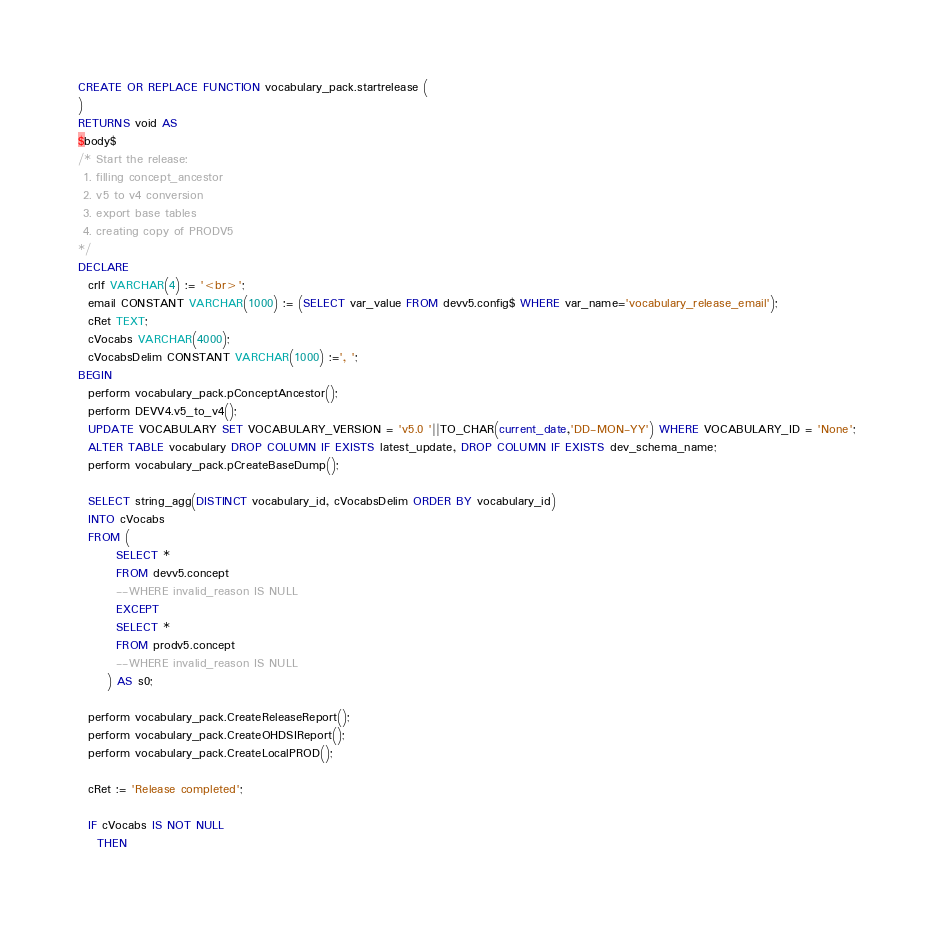Convert code to text. <code><loc_0><loc_0><loc_500><loc_500><_SQL_>CREATE OR REPLACE FUNCTION vocabulary_pack.startrelease (
)
RETURNS void AS
$body$
/* Start the release: 
 1. filling concept_ancestor 
 2. v5 to v4 conversion
 3. export base tables
 4. creating copy of PRODV5
*/
DECLARE
  crlf VARCHAR(4) := '<br>';
  email CONSTANT VARCHAR(1000) := (SELECT var_value FROM devv5.config$ WHERE var_name='vocabulary_release_email');
  cRet TEXT;
  cVocabs VARCHAR(4000);
  cVocabsDelim CONSTANT VARCHAR(1000) :=', ';
BEGIN
  perform vocabulary_pack.pConceptAncestor();
  perform DEVV4.v5_to_v4();
  UPDATE VOCABULARY SET VOCABULARY_VERSION = 'v5.0 '||TO_CHAR(current_date,'DD-MON-YY') WHERE VOCABULARY_ID = 'None';
  ALTER TABLE vocabulary DROP COLUMN IF EXISTS latest_update, DROP COLUMN IF EXISTS dev_schema_name;
  perform vocabulary_pack.pCreateBaseDump();
  
  SELECT string_agg(DISTINCT vocabulary_id, cVocabsDelim ORDER BY vocabulary_id)
  INTO cVocabs
  FROM (
        SELECT *
        FROM devv5.concept
        --WHERE invalid_reason IS NULL
        EXCEPT
        SELECT *
        FROM prodv5.concept
        --WHERE invalid_reason IS NULL
      ) AS s0;

  perform vocabulary_pack.CreateReleaseReport();
  perform vocabulary_pack.CreateOHDSIReport();
  perform vocabulary_pack.CreateLocalPROD();
  
  cRet := 'Release completed';

  IF cVocabs IS NOT NULL
    THEN</code> 